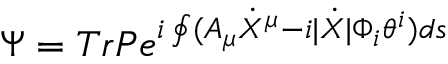<formula> <loc_0><loc_0><loc_500><loc_500>\Psi = T r P e ^ { i \oint ( A _ { \mu } \dot { X } ^ { \mu } - i | \dot { X } | \Phi _ { i } \theta ^ { i } ) d s }</formula> 